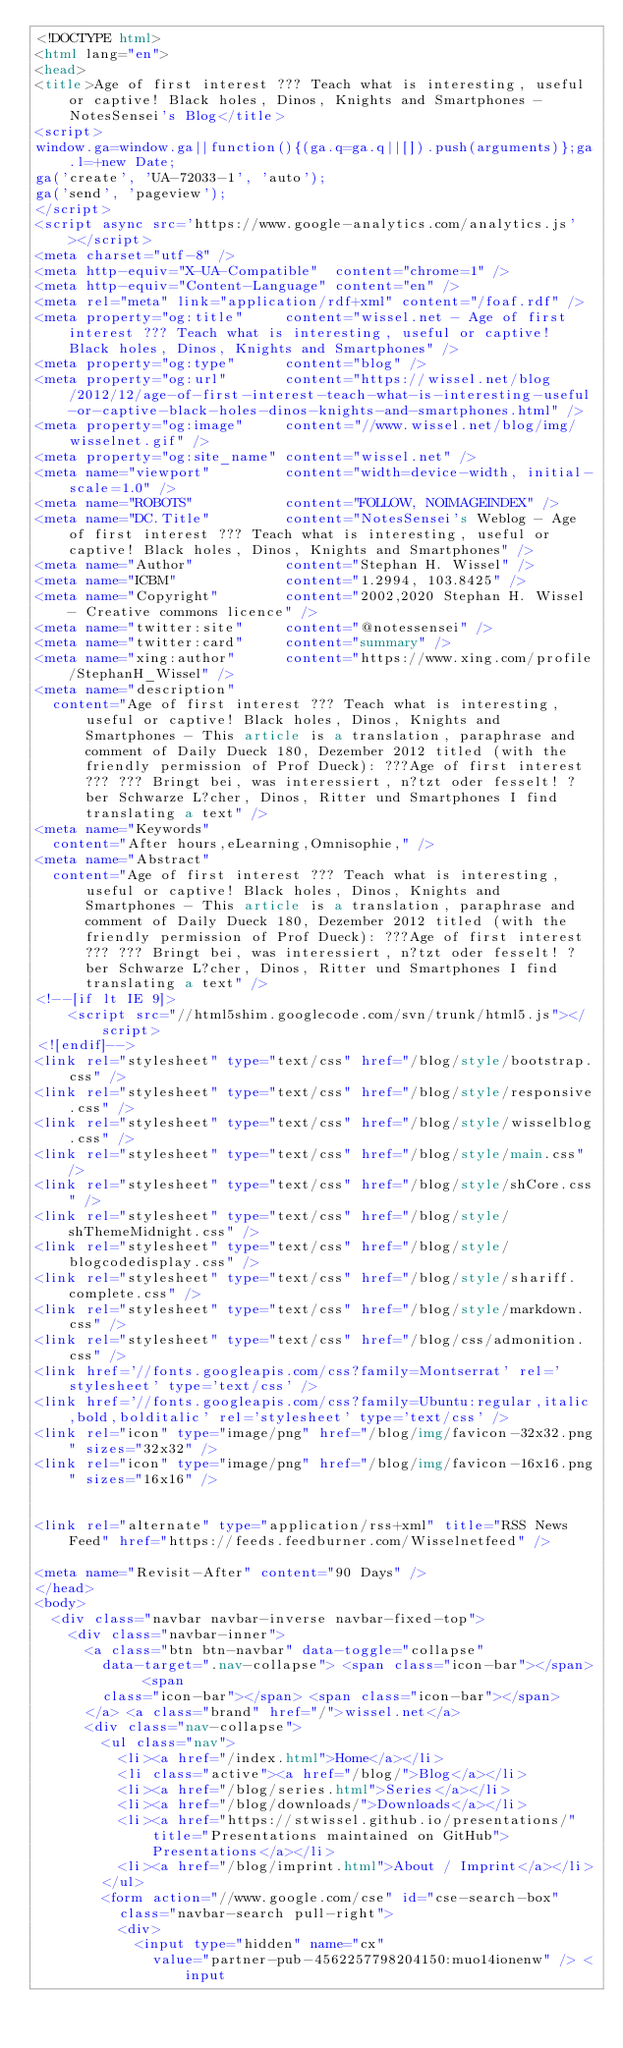<code> <loc_0><loc_0><loc_500><loc_500><_HTML_><!DOCTYPE html>
<html lang="en">
<head>
<title>Age of first interest ??? Teach what is interesting, useful or captive! Black holes, Dinos, Knights and Smartphones - NotesSensei's Blog</title>
<script>
window.ga=window.ga||function(){(ga.q=ga.q||[]).push(arguments)};ga.l=+new Date;
ga('create', 'UA-72033-1', 'auto');
ga('send', 'pageview');
</script>
<script async src='https://www.google-analytics.com/analytics.js'></script>
<meta charset="utf-8" />
<meta http-equiv="X-UA-Compatible"  content="chrome=1" />
<meta http-equiv="Content-Language" content="en" />
<meta rel="meta" link="application/rdf+xml" content="/foaf.rdf" />
<meta property="og:title"     content="wissel.net - Age of first interest ??? Teach what is interesting, useful or captive! Black holes, Dinos, Knights and Smartphones" />
<meta property="og:type"      content="blog" />
<meta property="og:url"       content="https://wissel.net/blog/2012/12/age-of-first-interest-teach-what-is-interesting-useful-or-captive-black-holes-dinos-knights-and-smartphones.html" />
<meta property="og:image"     content="//www.wissel.net/blog/img/wisselnet.gif" />
<meta property="og:site_name" content="wissel.net" />
<meta name="viewport"         content="width=device-width, initial-scale=1.0" />
<meta name="ROBOTS"           content="FOLLOW, NOIMAGEINDEX" />
<meta name="DC.Title"         content="NotesSensei's Weblog - Age of first interest ??? Teach what is interesting, useful or captive! Black holes, Dinos, Knights and Smartphones" />
<meta name="Author"           content="Stephan H. Wissel" />
<meta name="ICBM"             content="1.2994, 103.8425" />
<meta name="Copyright"        content="2002,2020 Stephan H. Wissel - Creative commons licence" />
<meta name="twitter:site"     content="@notessensei" />
<meta name="twitter:card"     content="summary" />
<meta name="xing:author"      content="https://www.xing.com/profile/StephanH_Wissel" />
<meta name="description"
	content="Age of first interest ??? Teach what is interesting, useful or captive! Black holes, Dinos, Knights and Smartphones - This article is a translation, paraphrase and comment of Daily Dueck 180, Dezember 2012 titled (with the friendly permission of Prof Dueck): ???Age of first interest??? ??? Bringt bei, was interessiert, n?tzt oder fesselt! ?ber Schwarze L?cher, Dinos, Ritter und Smartphones I find translating a text" />
<meta name="Keywords"
	content="After hours,eLearning,Omnisophie," />
<meta name="Abstract"
	content="Age of first interest ??? Teach what is interesting, useful or captive! Black holes, Dinos, Knights and Smartphones - This article is a translation, paraphrase and comment of Daily Dueck 180, Dezember 2012 titled (with the friendly permission of Prof Dueck): ???Age of first interest??? ??? Bringt bei, was interessiert, n?tzt oder fesselt! ?ber Schwarze L?cher, Dinos, Ritter und Smartphones I find translating a text" />
<!--[if lt IE 9]>
		<script src="//html5shim.googlecode.com/svn/trunk/html5.js"></script>
<![endif]-->
<link rel="stylesheet" type="text/css" href="/blog/style/bootstrap.css" />
<link rel="stylesheet" type="text/css" href="/blog/style/responsive.css" />
<link rel="stylesheet" type="text/css" href="/blog/style/wisselblog.css" />
<link rel="stylesheet" type="text/css" href="/blog/style/main.css" />
<link rel="stylesheet" type="text/css" href="/blog/style/shCore.css" />
<link rel="stylesheet" type="text/css" href="/blog/style/shThemeMidnight.css" />
<link rel="stylesheet" type="text/css" href="/blog/style/blogcodedisplay.css" />
<link rel="stylesheet" type="text/css" href="/blog/style/shariff.complete.css" />
<link rel="stylesheet" type="text/css" href="/blog/style/markdown.css" />
<link rel="stylesheet" type="text/css" href="/blog/css/admonition.css" />
<link href='//fonts.googleapis.com/css?family=Montserrat' rel='stylesheet' type='text/css' />
<link href='//fonts.googleapis.com/css?family=Ubuntu:regular,italic,bold,bolditalic' rel='stylesheet' type='text/css' />
<link rel="icon" type="image/png" href="/blog/img/favicon-32x32.png" sizes="32x32" />
<link rel="icon" type="image/png" href="/blog/img/favicon-16x16.png" sizes="16x16" />


<link rel="alternate" type="application/rss+xml" title="RSS News Feed" href="https://feeds.feedburner.com/Wisselnetfeed" />

<meta name="Revisit-After" content="90 Days" />
</head>
<body>
	<div class="navbar navbar-inverse navbar-fixed-top">
		<div class="navbar-inner">
			<a class="btn btn-navbar" data-toggle="collapse"
				data-target=".nav-collapse"> <span class="icon-bar"></span> <span
				class="icon-bar"></span> <span class="icon-bar"></span>
			</a> <a class="brand" href="/">wissel.net</a>
			<div class="nav-collapse">
				<ul class="nav">
					<li><a href="/index.html">Home</a></li>
					<li class="active"><a href="/blog/">Blog</a></li>
					<li><a href="/blog/series.html">Series</a></li>
					<li><a href="/blog/downloads/">Downloads</a></li>
					<li><a href="https://stwissel.github.io/presentations/" title="Presentations maintained on GitHub">Presentations</a></li>
					<li><a href="/blog/imprint.html">About / Imprint</a></li>
				</ul>
				<form action="//www.google.com/cse" id="cse-search-box"
					class="navbar-search pull-right">
					<div>
						<input type="hidden" name="cx"
							value="partner-pub-4562257798204150:muo14ionenw" /> <input</code> 